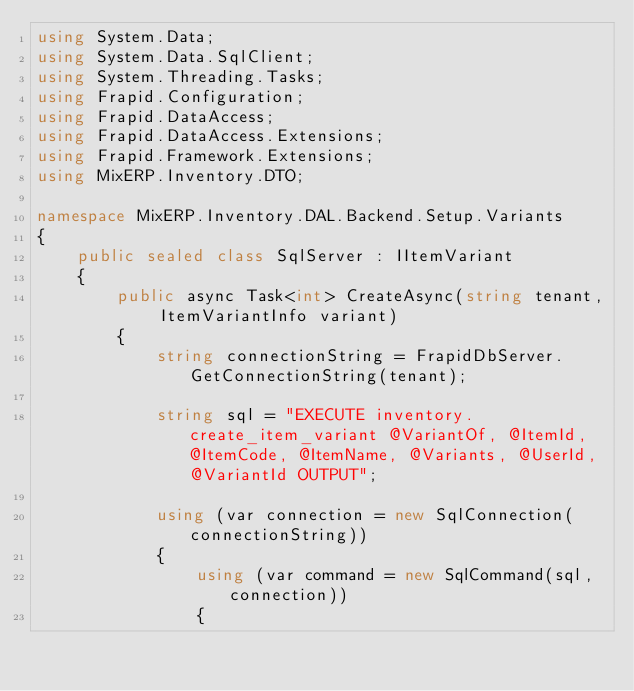Convert code to text. <code><loc_0><loc_0><loc_500><loc_500><_C#_>using System.Data;
using System.Data.SqlClient;
using System.Threading.Tasks;
using Frapid.Configuration;
using Frapid.DataAccess;
using Frapid.DataAccess.Extensions;
using Frapid.Framework.Extensions;
using MixERP.Inventory.DTO;

namespace MixERP.Inventory.DAL.Backend.Setup.Variants
{
    public sealed class SqlServer : IItemVariant
    {
        public async Task<int> CreateAsync(string tenant, ItemVariantInfo variant)
        {
            string connectionString = FrapidDbServer.GetConnectionString(tenant);

            string sql = "EXECUTE inventory.create_item_variant @VariantOf, @ItemId, @ItemCode, @ItemName, @Variants, @UserId, @VariantId OUTPUT";

            using (var connection = new SqlConnection(connectionString))
            {
                using (var command = new SqlCommand(sql, connection))
                {</code> 